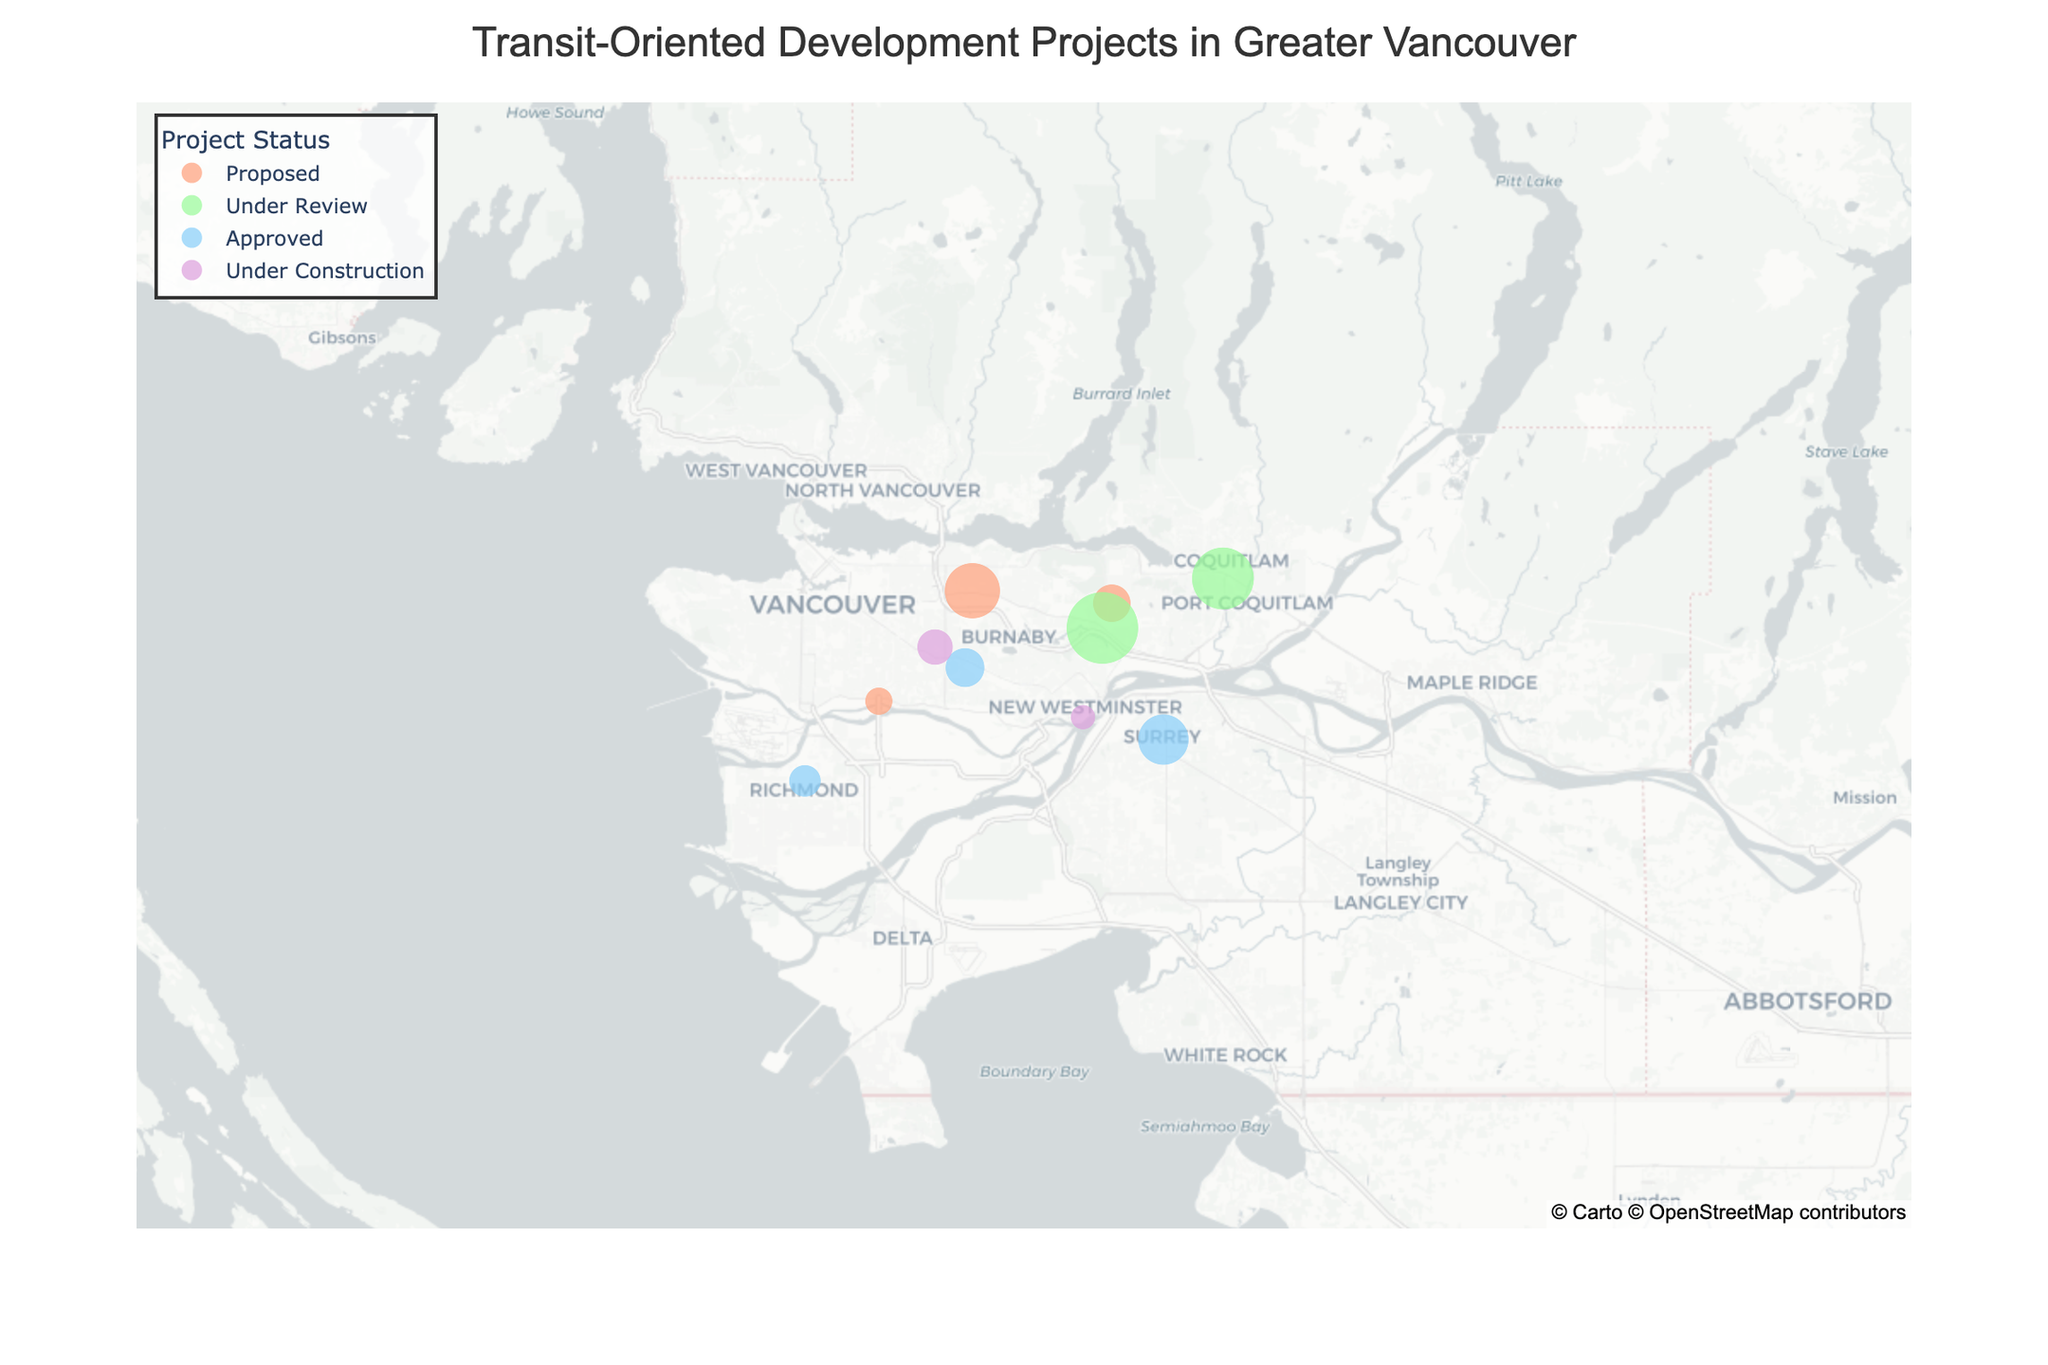What's the title of the figure? The title is usually found at the top of the figure and summarizes the content or the main focus of the visual. In this case, the title is clearly specified in the figure's layout configuration.
Answer: Transit-Oriented Development Projects in Greater Vancouver How many projects are proposed? By examining the color and the legend that matches "Proposed" projects, we can count the number of data points that share this color. There are four data points indicated for "Proposed" projects.
Answer: 4 Which project has the highest number of units? By observing the size of the markers and referencing the hover information, we can identify which marker represents the largest number of units. The "Lougheed Town Centre Master Plan" has 10,000 units.
Answer: Lougheed Town Centre Master Plan What's the total number of units for projects that are approved? We need to identify the data points marked as "Approved" and sum their units. The approved projects are "Concord Metrotown," "Centre Block Development," and "Richmond Centre South" with 3000, 5000, and 2000 units respectively. Summing them gives 3000 + 5000 + 2000 = 10,000.
Answer: 10,000 Which station has the most under construction units? By looking at the size of markers tagged as "Under Construction" in the hover data or legend, "Joyce-Collingwood Station Precinct Plan" has 2500 units.
Answer: Joyce-Collingwood Station Precinct Plan Are proposed projects more frequent than approved projects? Comparing the numbers, there are 4 proposed and 3 approved projects based on their respective colors in the legend.
Answer: Yes What’s the average number of units for projects under review? We identify the units for each "Under Review" project and calculate their mean. The projects are "Lougheed Town Centre Master Plan" with 10,000 units and "Coquitlam Centre Redevelopment" with 7,500 units. (10000 + 7500) / 2 = 8,750.
Answer: 8,750 Which proposed project has the fewest units? By checking the size and the hover data of markers for "Proposed" projects, the smallest unit number is for "Marine Gateway 2" which has 1500 units.
Answer: Marine Gateway 2 How many projects are under construction? By counting the number of data points tagged with "Under Construction" from the legend, there are two projects indicated.
Answer: 2 Which project is located furthest south? We need to compare the latitude values, and the one with the smallest latitude is the furthest south. "Richmond Centre South" is the furthest south with a latitude of 49.1680.
Answer: Richmond Centre South 